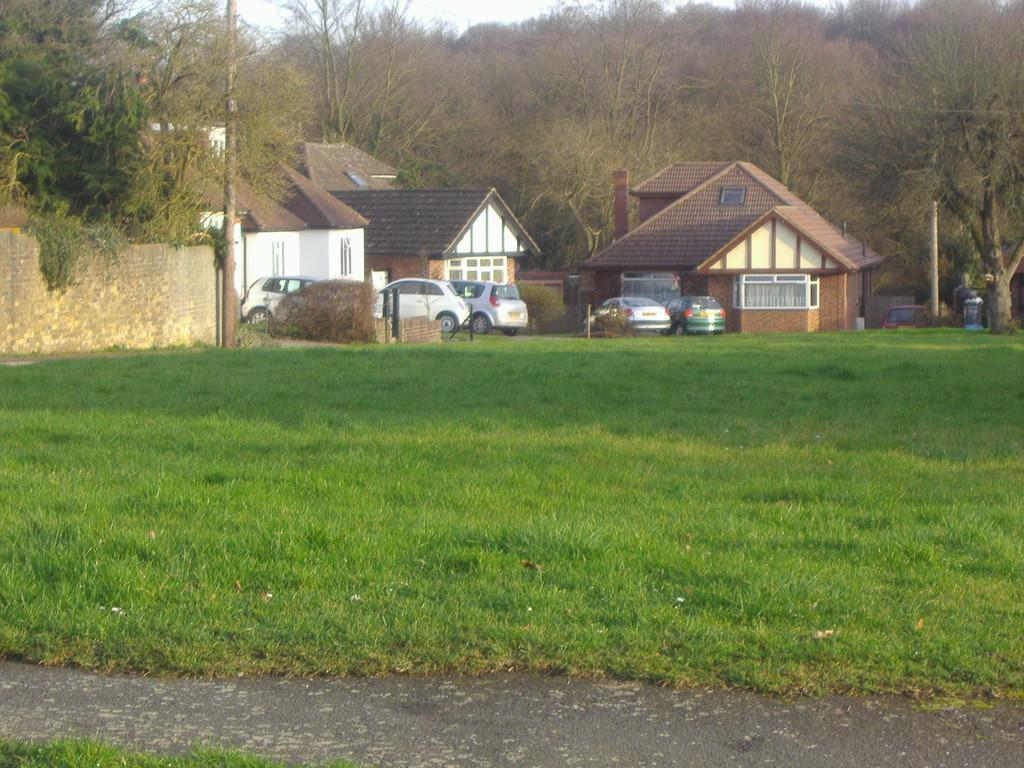What type of terrain is present in the image? There is a grass area in the image. What can be seen in the distance behind the grass area? There are vehicles visible on a road and houses in the background. What type of vegetation surrounds the houses? Trees are surrounding the houses. What type of clover is growing on the roof of the houses in the image? There is no clover visible on the roofs of the houses in the image. What point is being made by the presence of the vehicles on the road in the image? The presence of vehicles on the road does not indicate a specific point or message; it simply shows that there is a road with vehicles in the background of the image. 